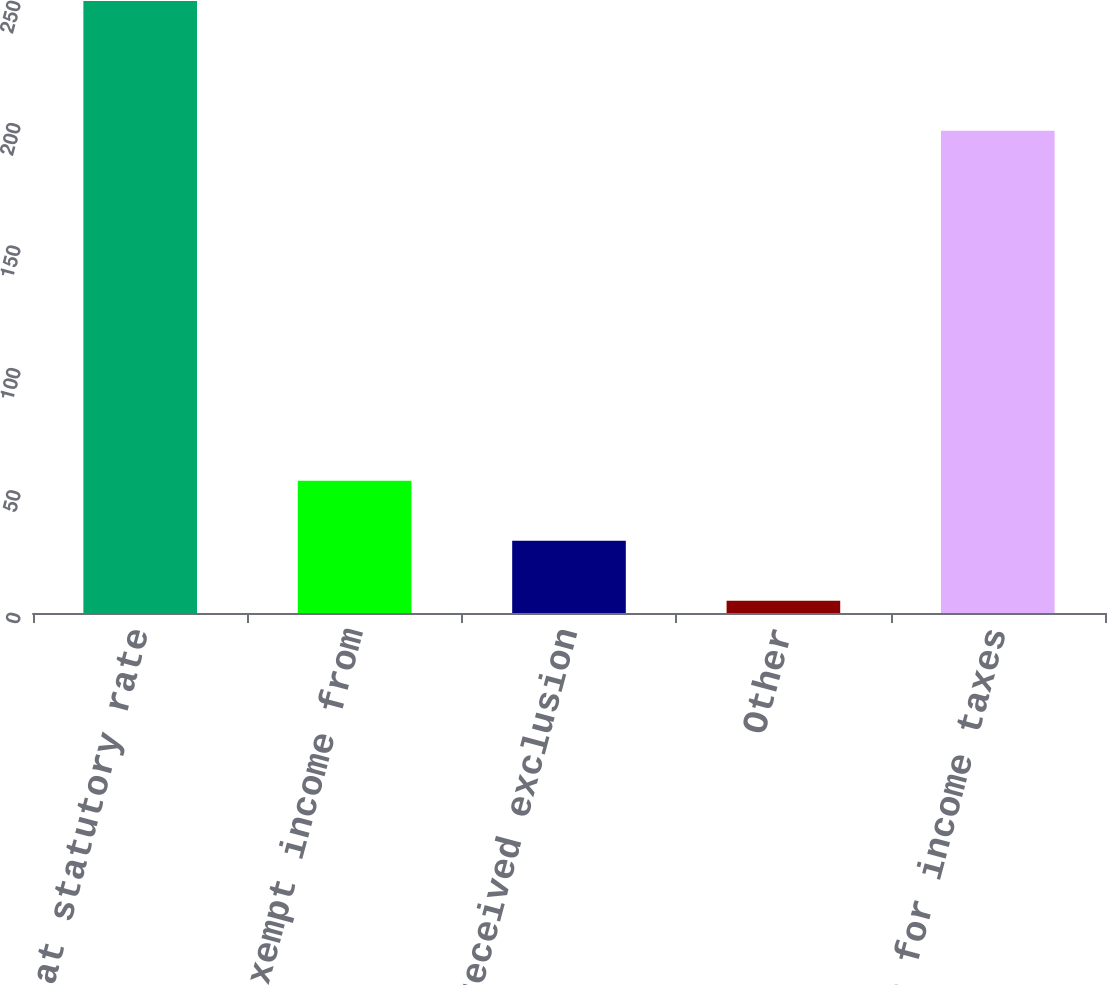Convert chart to OTSL. <chart><loc_0><loc_0><loc_500><loc_500><bar_chart><fcel>Tax at statutory rate<fcel>Tax-exempt income from<fcel>Dividend received exclusion<fcel>Other<fcel>Provision for income taxes<nl><fcel>250<fcel>54<fcel>29.5<fcel>5<fcel>197<nl></chart> 